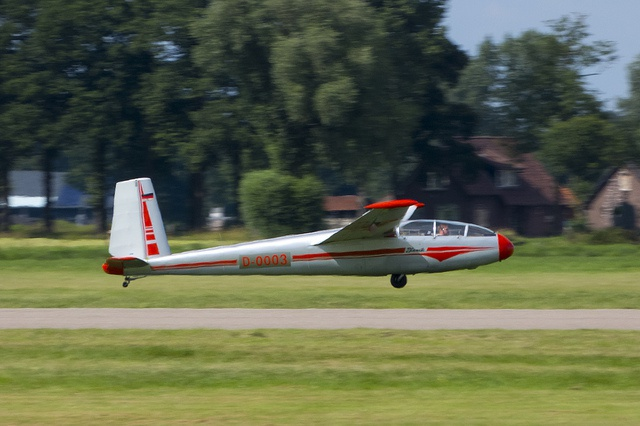Describe the objects in this image and their specific colors. I can see airplane in black, gray, lightgray, and darkgray tones and people in black, gray, salmon, and darkgray tones in this image. 